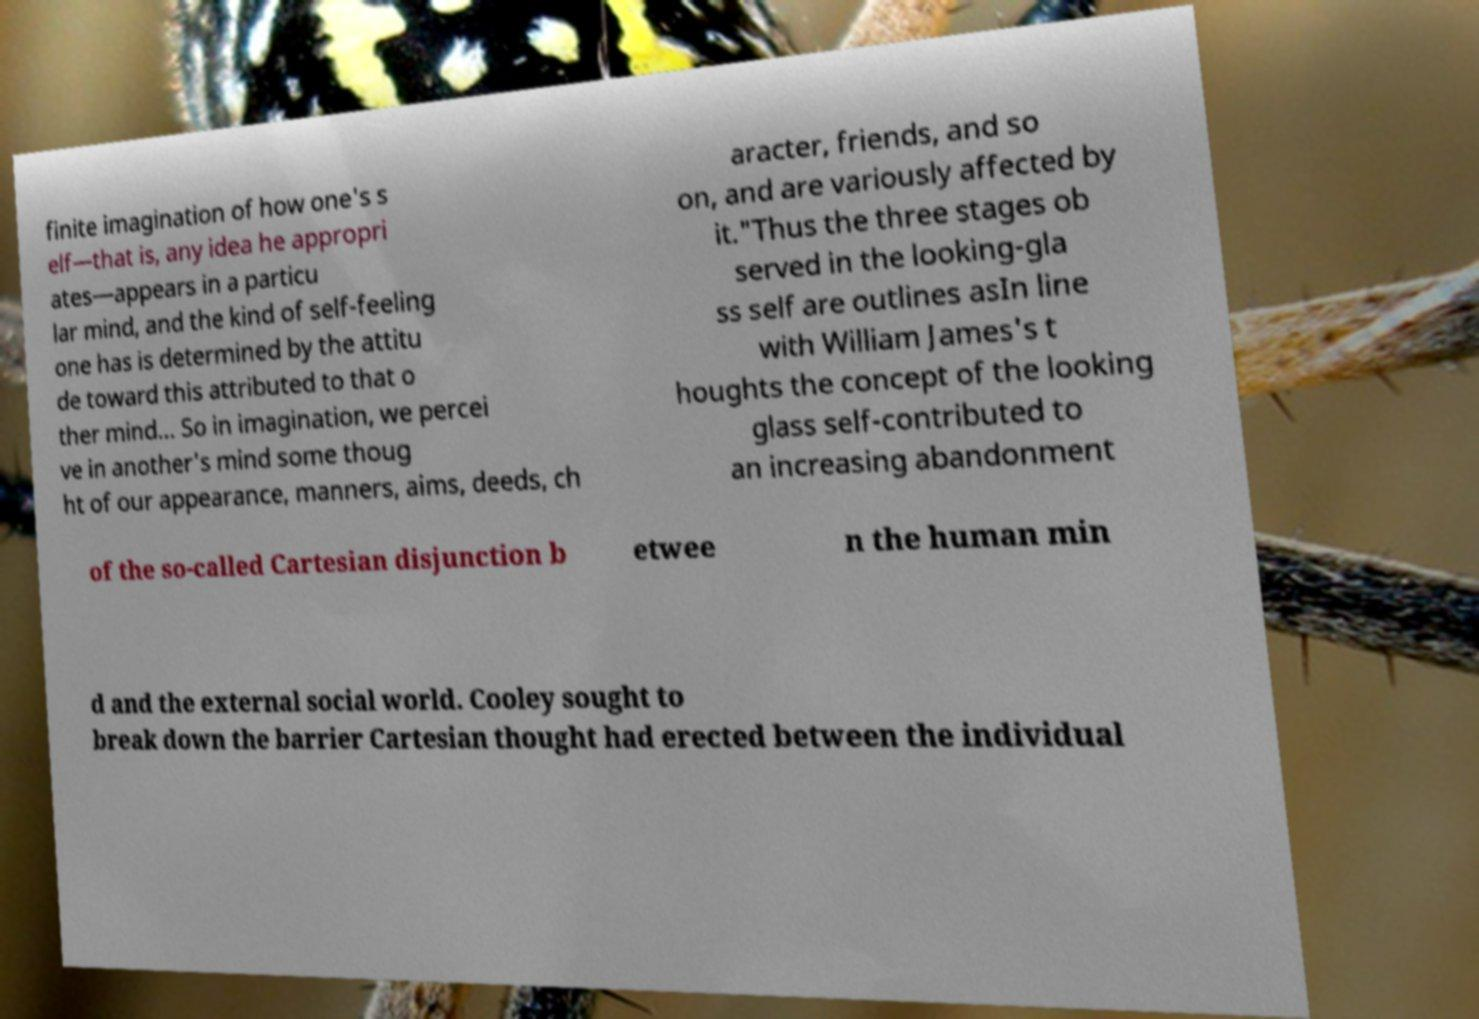Please identify and transcribe the text found in this image. finite imagination of how one's s elf—that is, any idea he appropri ates—appears in a particu lar mind, and the kind of self-feeling one has is determined by the attitu de toward this attributed to that o ther mind... So in imagination, we percei ve in another's mind some thoug ht of our appearance, manners, aims, deeds, ch aracter, friends, and so on, and are variously affected by it."Thus the three stages ob served in the looking-gla ss self are outlines asIn line with William James's t houghts the concept of the looking glass self-contributed to an increasing abandonment of the so-called Cartesian disjunction b etwee n the human min d and the external social world. Cooley sought to break down the barrier Cartesian thought had erected between the individual 